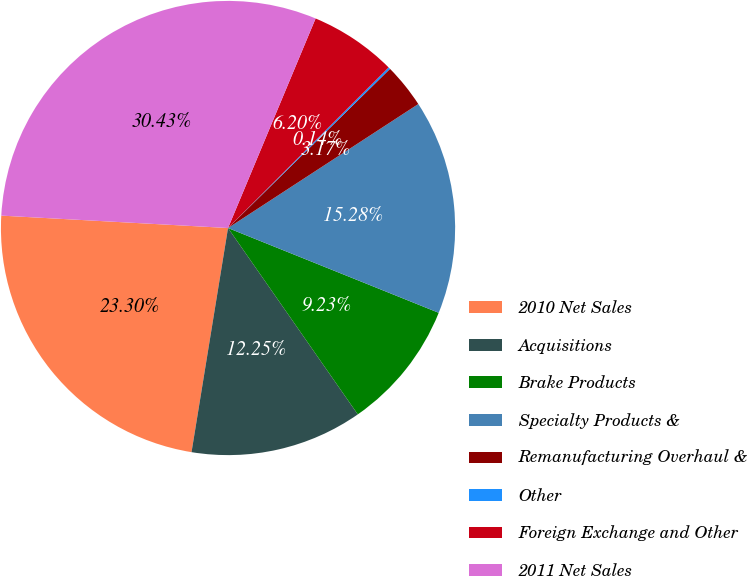<chart> <loc_0><loc_0><loc_500><loc_500><pie_chart><fcel>2010 Net Sales<fcel>Acquisitions<fcel>Brake Products<fcel>Specialty Products &<fcel>Remanufacturing Overhaul &<fcel>Other<fcel>Foreign Exchange and Other<fcel>2011 Net Sales<nl><fcel>23.3%<fcel>12.25%<fcel>9.23%<fcel>15.28%<fcel>3.17%<fcel>0.14%<fcel>6.2%<fcel>30.43%<nl></chart> 